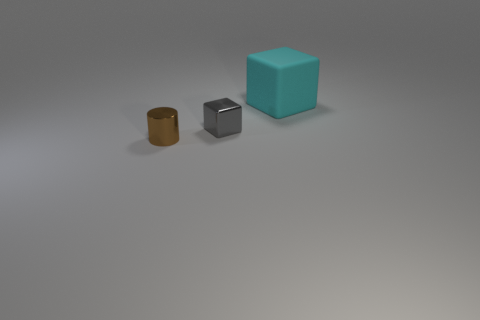There is a big cyan rubber cube that is behind the metal cylinder; is there a cube that is in front of it?
Provide a short and direct response. Yes. What number of other things are the same color as the matte thing?
Your answer should be compact. 0. The cyan object has what size?
Make the answer very short. Large. Are there any red metallic things?
Ensure brevity in your answer.  No. Are there more large cyan matte cubes right of the small cube than large rubber objects that are left of the large cube?
Give a very brief answer. Yes. There is a thing that is both left of the big thing and behind the brown shiny cylinder; what material is it?
Keep it short and to the point. Metal. Is the large cyan object the same shape as the small brown object?
Your answer should be compact. No. Are there any other things that have the same size as the matte cube?
Make the answer very short. No. There is a brown cylinder; what number of cyan objects are behind it?
Provide a succinct answer. 1. Do the cube that is in front of the rubber thing and the tiny brown metallic cylinder have the same size?
Make the answer very short. Yes. 